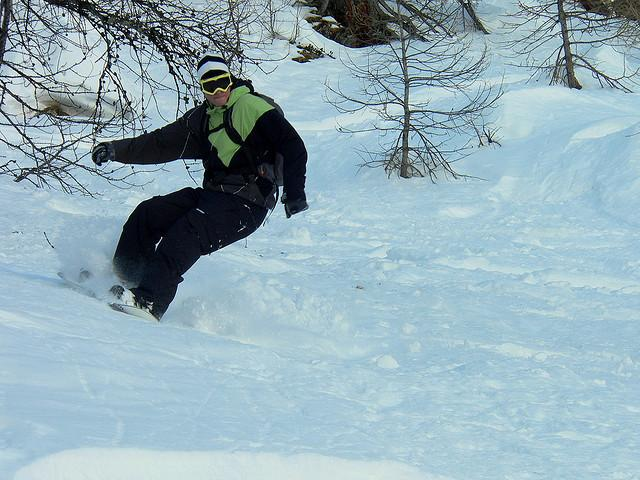What is the man wearing?

Choices:
A) goggles
B) bandana
C) potato sack
D) garbage bag goggles 